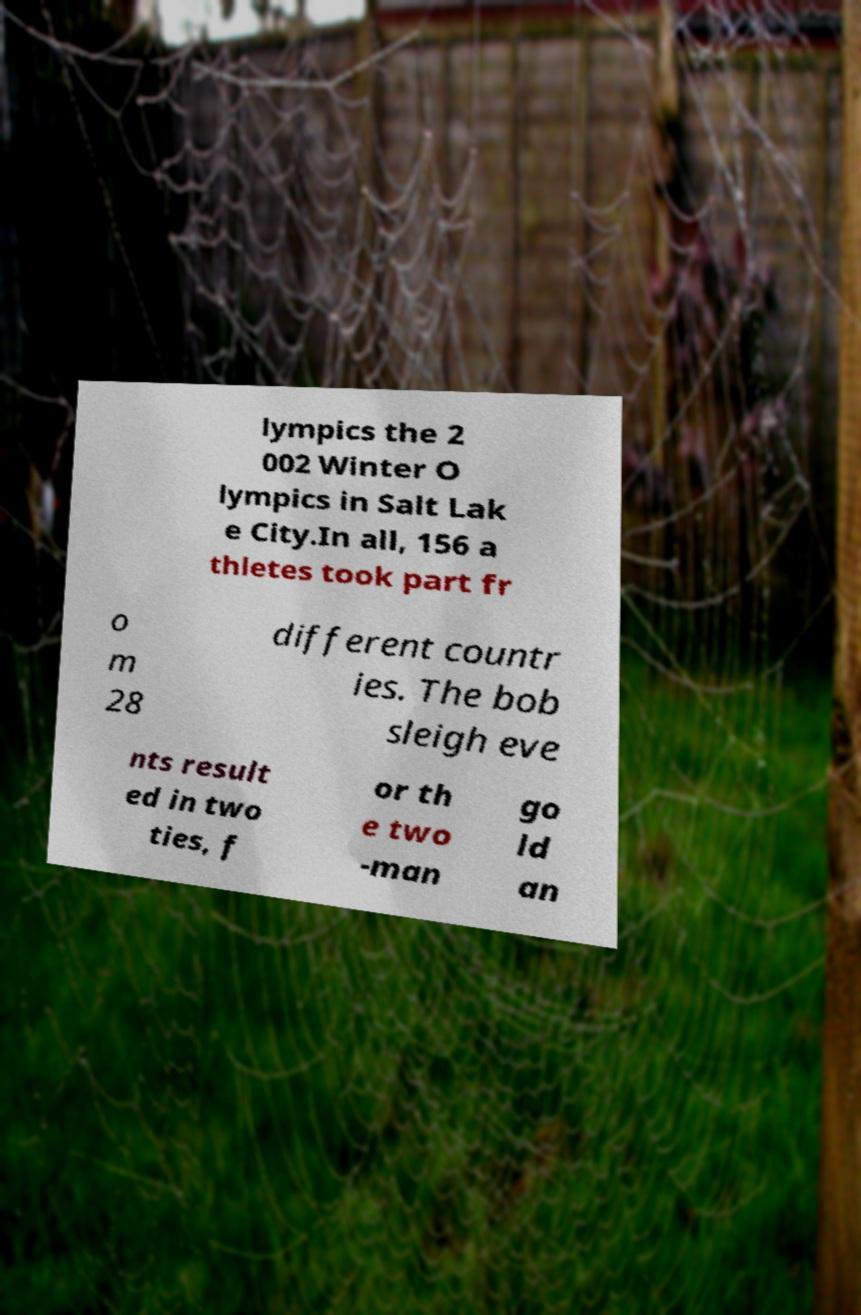I need the written content from this picture converted into text. Can you do that? lympics the 2 002 Winter O lympics in Salt Lak e City.In all, 156 a thletes took part fr o m 28 different countr ies. The bob sleigh eve nts result ed in two ties, f or th e two -man go ld an 